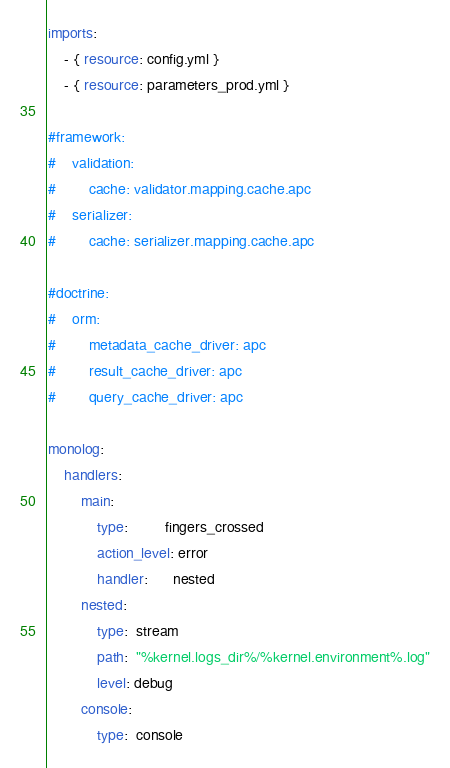<code> <loc_0><loc_0><loc_500><loc_500><_YAML_>imports:
    - { resource: config.yml }
    - { resource: parameters_prod.yml }

#framework:
#    validation:
#        cache: validator.mapping.cache.apc
#    serializer:
#        cache: serializer.mapping.cache.apc

#doctrine:
#    orm:
#        metadata_cache_driver: apc
#        result_cache_driver: apc
#        query_cache_driver: apc

monolog:
    handlers:
        main:
            type:         fingers_crossed
            action_level: error
            handler:      nested
        nested:
            type:  stream
            path:  "%kernel.logs_dir%/%kernel.environment%.log"
            level: debug
        console:
            type:  console
</code> 